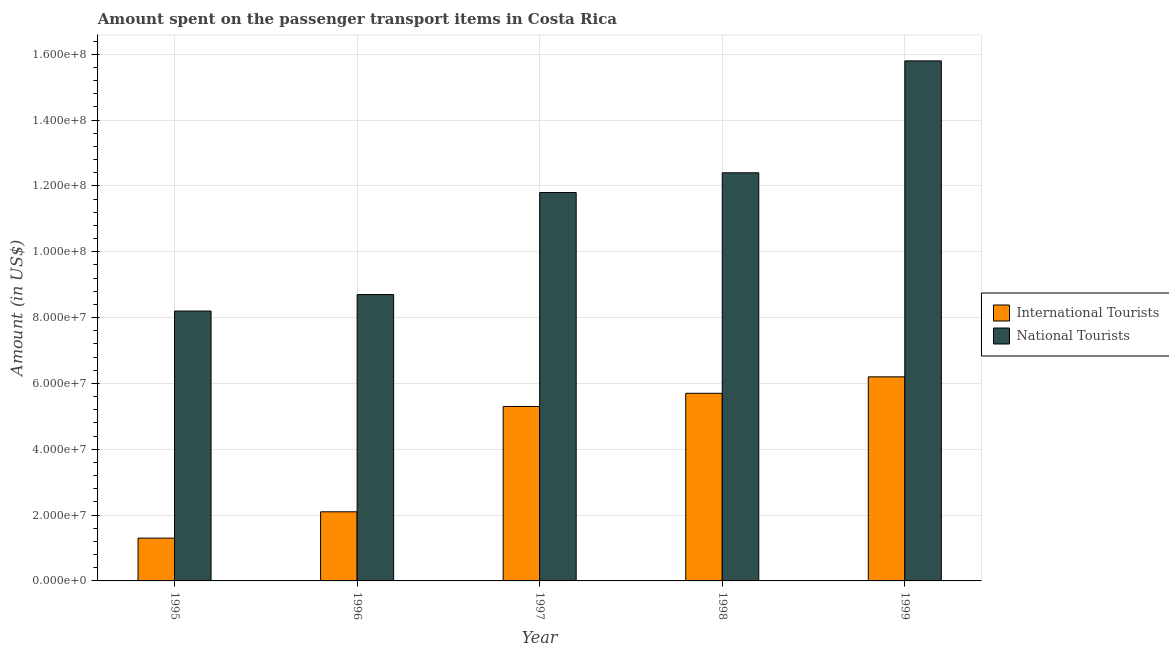How many different coloured bars are there?
Your answer should be very brief. 2. How many groups of bars are there?
Your answer should be compact. 5. What is the amount spent on transport items of international tourists in 1998?
Make the answer very short. 5.70e+07. Across all years, what is the maximum amount spent on transport items of international tourists?
Offer a very short reply. 6.20e+07. Across all years, what is the minimum amount spent on transport items of international tourists?
Your answer should be very brief. 1.30e+07. In which year was the amount spent on transport items of national tourists minimum?
Offer a very short reply. 1995. What is the total amount spent on transport items of international tourists in the graph?
Ensure brevity in your answer.  2.06e+08. What is the difference between the amount spent on transport items of national tourists in 1998 and that in 1999?
Your answer should be very brief. -3.40e+07. What is the difference between the amount spent on transport items of national tourists in 1996 and the amount spent on transport items of international tourists in 1995?
Keep it short and to the point. 5.00e+06. What is the average amount spent on transport items of national tourists per year?
Give a very brief answer. 1.14e+08. In how many years, is the amount spent on transport items of national tourists greater than 112000000 US$?
Provide a short and direct response. 3. What is the ratio of the amount spent on transport items of international tourists in 1997 to that in 1998?
Give a very brief answer. 0.93. What is the difference between the highest and the second highest amount spent on transport items of international tourists?
Provide a succinct answer. 5.00e+06. What is the difference between the highest and the lowest amount spent on transport items of international tourists?
Your response must be concise. 4.90e+07. What does the 2nd bar from the left in 1995 represents?
Make the answer very short. National Tourists. What does the 2nd bar from the right in 1995 represents?
Keep it short and to the point. International Tourists. How many bars are there?
Offer a very short reply. 10. Are all the bars in the graph horizontal?
Ensure brevity in your answer.  No. How many years are there in the graph?
Keep it short and to the point. 5. What is the difference between two consecutive major ticks on the Y-axis?
Offer a terse response. 2.00e+07. How many legend labels are there?
Offer a very short reply. 2. What is the title of the graph?
Your answer should be very brief. Amount spent on the passenger transport items in Costa Rica. What is the label or title of the X-axis?
Give a very brief answer. Year. What is the label or title of the Y-axis?
Provide a short and direct response. Amount (in US$). What is the Amount (in US$) of International Tourists in 1995?
Keep it short and to the point. 1.30e+07. What is the Amount (in US$) in National Tourists in 1995?
Provide a short and direct response. 8.20e+07. What is the Amount (in US$) of International Tourists in 1996?
Offer a terse response. 2.10e+07. What is the Amount (in US$) in National Tourists in 1996?
Your response must be concise. 8.70e+07. What is the Amount (in US$) of International Tourists in 1997?
Ensure brevity in your answer.  5.30e+07. What is the Amount (in US$) of National Tourists in 1997?
Offer a very short reply. 1.18e+08. What is the Amount (in US$) of International Tourists in 1998?
Keep it short and to the point. 5.70e+07. What is the Amount (in US$) of National Tourists in 1998?
Offer a terse response. 1.24e+08. What is the Amount (in US$) in International Tourists in 1999?
Provide a short and direct response. 6.20e+07. What is the Amount (in US$) in National Tourists in 1999?
Your answer should be very brief. 1.58e+08. Across all years, what is the maximum Amount (in US$) in International Tourists?
Make the answer very short. 6.20e+07. Across all years, what is the maximum Amount (in US$) of National Tourists?
Keep it short and to the point. 1.58e+08. Across all years, what is the minimum Amount (in US$) of International Tourists?
Your answer should be compact. 1.30e+07. Across all years, what is the minimum Amount (in US$) of National Tourists?
Provide a succinct answer. 8.20e+07. What is the total Amount (in US$) in International Tourists in the graph?
Give a very brief answer. 2.06e+08. What is the total Amount (in US$) in National Tourists in the graph?
Offer a very short reply. 5.69e+08. What is the difference between the Amount (in US$) in International Tourists in 1995 and that in 1996?
Ensure brevity in your answer.  -8.00e+06. What is the difference between the Amount (in US$) in National Tourists in 1995 and that in 1996?
Your response must be concise. -5.00e+06. What is the difference between the Amount (in US$) of International Tourists in 1995 and that in 1997?
Give a very brief answer. -4.00e+07. What is the difference between the Amount (in US$) in National Tourists in 1995 and that in 1997?
Give a very brief answer. -3.60e+07. What is the difference between the Amount (in US$) in International Tourists in 1995 and that in 1998?
Offer a terse response. -4.40e+07. What is the difference between the Amount (in US$) in National Tourists in 1995 and that in 1998?
Your response must be concise. -4.20e+07. What is the difference between the Amount (in US$) of International Tourists in 1995 and that in 1999?
Your answer should be very brief. -4.90e+07. What is the difference between the Amount (in US$) in National Tourists in 1995 and that in 1999?
Offer a terse response. -7.60e+07. What is the difference between the Amount (in US$) of International Tourists in 1996 and that in 1997?
Your answer should be very brief. -3.20e+07. What is the difference between the Amount (in US$) in National Tourists in 1996 and that in 1997?
Offer a very short reply. -3.10e+07. What is the difference between the Amount (in US$) in International Tourists in 1996 and that in 1998?
Your answer should be compact. -3.60e+07. What is the difference between the Amount (in US$) of National Tourists in 1996 and that in 1998?
Offer a terse response. -3.70e+07. What is the difference between the Amount (in US$) in International Tourists in 1996 and that in 1999?
Ensure brevity in your answer.  -4.10e+07. What is the difference between the Amount (in US$) of National Tourists in 1996 and that in 1999?
Make the answer very short. -7.10e+07. What is the difference between the Amount (in US$) of International Tourists in 1997 and that in 1998?
Your answer should be very brief. -4.00e+06. What is the difference between the Amount (in US$) of National Tourists in 1997 and that in 1998?
Your response must be concise. -6.00e+06. What is the difference between the Amount (in US$) of International Tourists in 1997 and that in 1999?
Your response must be concise. -9.00e+06. What is the difference between the Amount (in US$) of National Tourists in 1997 and that in 1999?
Offer a terse response. -4.00e+07. What is the difference between the Amount (in US$) in International Tourists in 1998 and that in 1999?
Your response must be concise. -5.00e+06. What is the difference between the Amount (in US$) of National Tourists in 1998 and that in 1999?
Your response must be concise. -3.40e+07. What is the difference between the Amount (in US$) of International Tourists in 1995 and the Amount (in US$) of National Tourists in 1996?
Provide a short and direct response. -7.40e+07. What is the difference between the Amount (in US$) in International Tourists in 1995 and the Amount (in US$) in National Tourists in 1997?
Your response must be concise. -1.05e+08. What is the difference between the Amount (in US$) of International Tourists in 1995 and the Amount (in US$) of National Tourists in 1998?
Give a very brief answer. -1.11e+08. What is the difference between the Amount (in US$) in International Tourists in 1995 and the Amount (in US$) in National Tourists in 1999?
Provide a succinct answer. -1.45e+08. What is the difference between the Amount (in US$) in International Tourists in 1996 and the Amount (in US$) in National Tourists in 1997?
Your answer should be compact. -9.70e+07. What is the difference between the Amount (in US$) of International Tourists in 1996 and the Amount (in US$) of National Tourists in 1998?
Ensure brevity in your answer.  -1.03e+08. What is the difference between the Amount (in US$) of International Tourists in 1996 and the Amount (in US$) of National Tourists in 1999?
Provide a short and direct response. -1.37e+08. What is the difference between the Amount (in US$) of International Tourists in 1997 and the Amount (in US$) of National Tourists in 1998?
Your response must be concise. -7.10e+07. What is the difference between the Amount (in US$) of International Tourists in 1997 and the Amount (in US$) of National Tourists in 1999?
Your answer should be compact. -1.05e+08. What is the difference between the Amount (in US$) of International Tourists in 1998 and the Amount (in US$) of National Tourists in 1999?
Keep it short and to the point. -1.01e+08. What is the average Amount (in US$) in International Tourists per year?
Give a very brief answer. 4.12e+07. What is the average Amount (in US$) of National Tourists per year?
Provide a short and direct response. 1.14e+08. In the year 1995, what is the difference between the Amount (in US$) of International Tourists and Amount (in US$) of National Tourists?
Provide a short and direct response. -6.90e+07. In the year 1996, what is the difference between the Amount (in US$) of International Tourists and Amount (in US$) of National Tourists?
Provide a succinct answer. -6.60e+07. In the year 1997, what is the difference between the Amount (in US$) of International Tourists and Amount (in US$) of National Tourists?
Your answer should be very brief. -6.50e+07. In the year 1998, what is the difference between the Amount (in US$) in International Tourists and Amount (in US$) in National Tourists?
Provide a succinct answer. -6.70e+07. In the year 1999, what is the difference between the Amount (in US$) of International Tourists and Amount (in US$) of National Tourists?
Offer a terse response. -9.60e+07. What is the ratio of the Amount (in US$) in International Tourists in 1995 to that in 1996?
Provide a succinct answer. 0.62. What is the ratio of the Amount (in US$) in National Tourists in 1995 to that in 1996?
Your answer should be very brief. 0.94. What is the ratio of the Amount (in US$) of International Tourists in 1995 to that in 1997?
Provide a succinct answer. 0.25. What is the ratio of the Amount (in US$) in National Tourists in 1995 to that in 1997?
Make the answer very short. 0.69. What is the ratio of the Amount (in US$) in International Tourists in 1995 to that in 1998?
Your response must be concise. 0.23. What is the ratio of the Amount (in US$) in National Tourists in 1995 to that in 1998?
Make the answer very short. 0.66. What is the ratio of the Amount (in US$) of International Tourists in 1995 to that in 1999?
Keep it short and to the point. 0.21. What is the ratio of the Amount (in US$) in National Tourists in 1995 to that in 1999?
Ensure brevity in your answer.  0.52. What is the ratio of the Amount (in US$) of International Tourists in 1996 to that in 1997?
Your answer should be very brief. 0.4. What is the ratio of the Amount (in US$) in National Tourists in 1996 to that in 1997?
Make the answer very short. 0.74. What is the ratio of the Amount (in US$) of International Tourists in 1996 to that in 1998?
Give a very brief answer. 0.37. What is the ratio of the Amount (in US$) in National Tourists in 1996 to that in 1998?
Give a very brief answer. 0.7. What is the ratio of the Amount (in US$) of International Tourists in 1996 to that in 1999?
Your answer should be compact. 0.34. What is the ratio of the Amount (in US$) of National Tourists in 1996 to that in 1999?
Give a very brief answer. 0.55. What is the ratio of the Amount (in US$) of International Tourists in 1997 to that in 1998?
Keep it short and to the point. 0.93. What is the ratio of the Amount (in US$) in National Tourists in 1997 to that in 1998?
Your answer should be very brief. 0.95. What is the ratio of the Amount (in US$) of International Tourists in 1997 to that in 1999?
Ensure brevity in your answer.  0.85. What is the ratio of the Amount (in US$) of National Tourists in 1997 to that in 1999?
Offer a very short reply. 0.75. What is the ratio of the Amount (in US$) of International Tourists in 1998 to that in 1999?
Keep it short and to the point. 0.92. What is the ratio of the Amount (in US$) in National Tourists in 1998 to that in 1999?
Make the answer very short. 0.78. What is the difference between the highest and the second highest Amount (in US$) in International Tourists?
Keep it short and to the point. 5.00e+06. What is the difference between the highest and the second highest Amount (in US$) in National Tourists?
Make the answer very short. 3.40e+07. What is the difference between the highest and the lowest Amount (in US$) in International Tourists?
Give a very brief answer. 4.90e+07. What is the difference between the highest and the lowest Amount (in US$) of National Tourists?
Make the answer very short. 7.60e+07. 